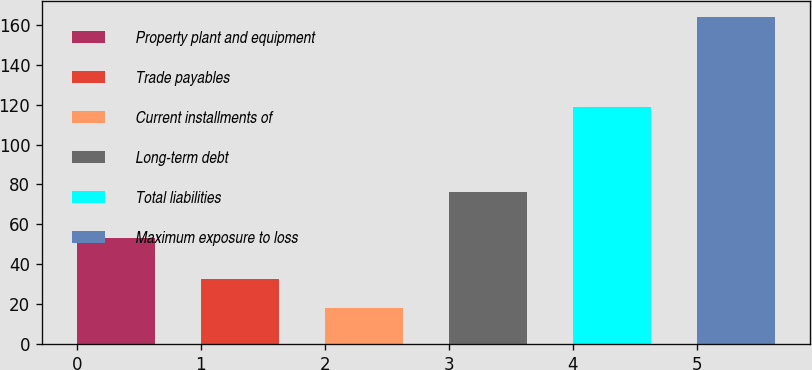<chart> <loc_0><loc_0><loc_500><loc_500><bar_chart><fcel>Property plant and equipment<fcel>Trade payables<fcel>Current installments of<fcel>Long-term debt<fcel>Total liabilities<fcel>Maximum exposure to loss<nl><fcel>53<fcel>32.6<fcel>18<fcel>76<fcel>119<fcel>164<nl></chart> 